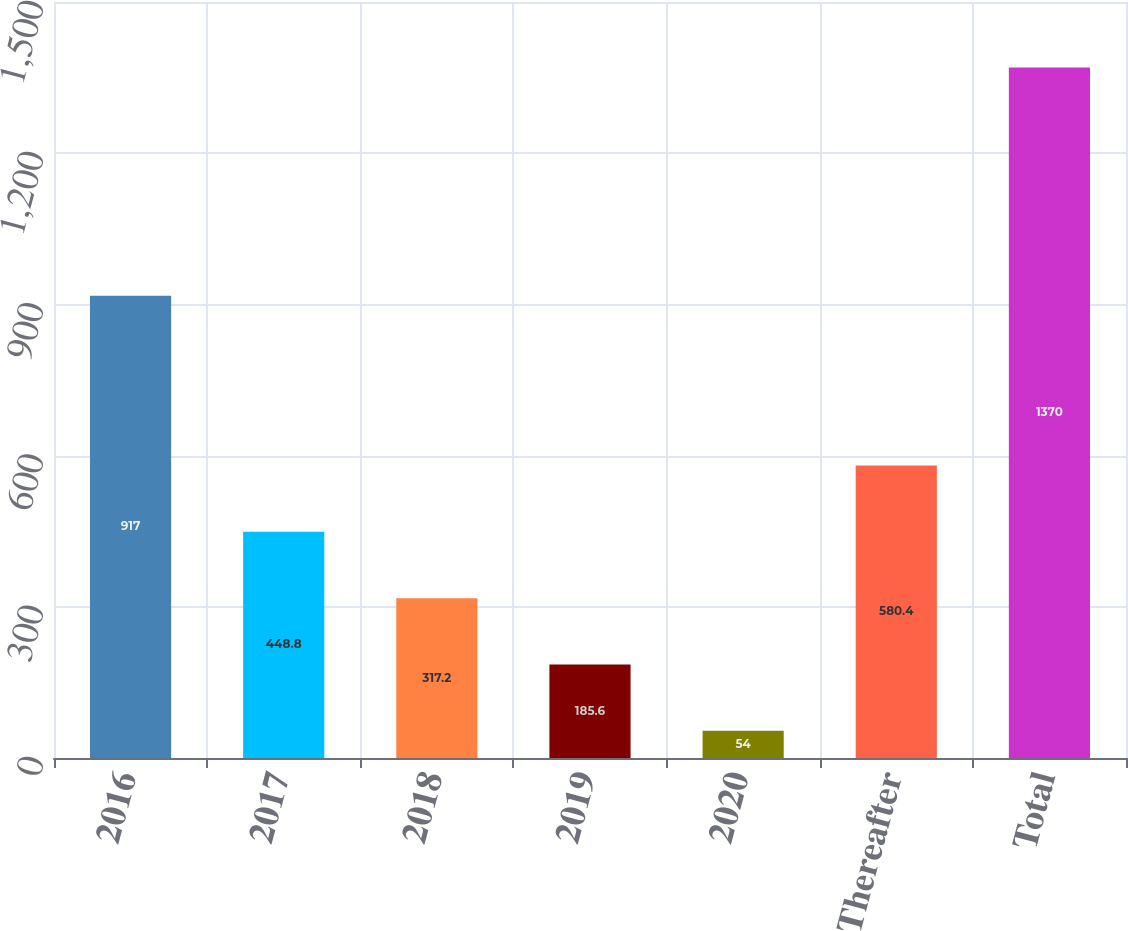Convert chart to OTSL. <chart><loc_0><loc_0><loc_500><loc_500><bar_chart><fcel>2016<fcel>2017<fcel>2018<fcel>2019<fcel>2020<fcel>Thereafter<fcel>Total<nl><fcel>917<fcel>448.8<fcel>317.2<fcel>185.6<fcel>54<fcel>580.4<fcel>1370<nl></chart> 